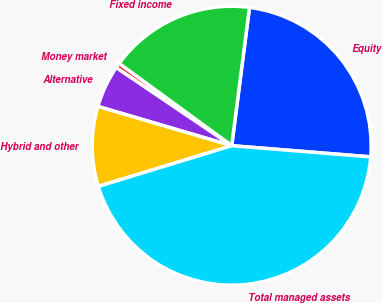Convert chart to OTSL. <chart><loc_0><loc_0><loc_500><loc_500><pie_chart><fcel>Equity<fcel>Fixed income<fcel>Money market<fcel>Alternative<fcel>Hybrid and other<fcel>Total managed assets<nl><fcel>24.24%<fcel>17.0%<fcel>0.57%<fcel>4.92%<fcel>9.26%<fcel>44.01%<nl></chart> 